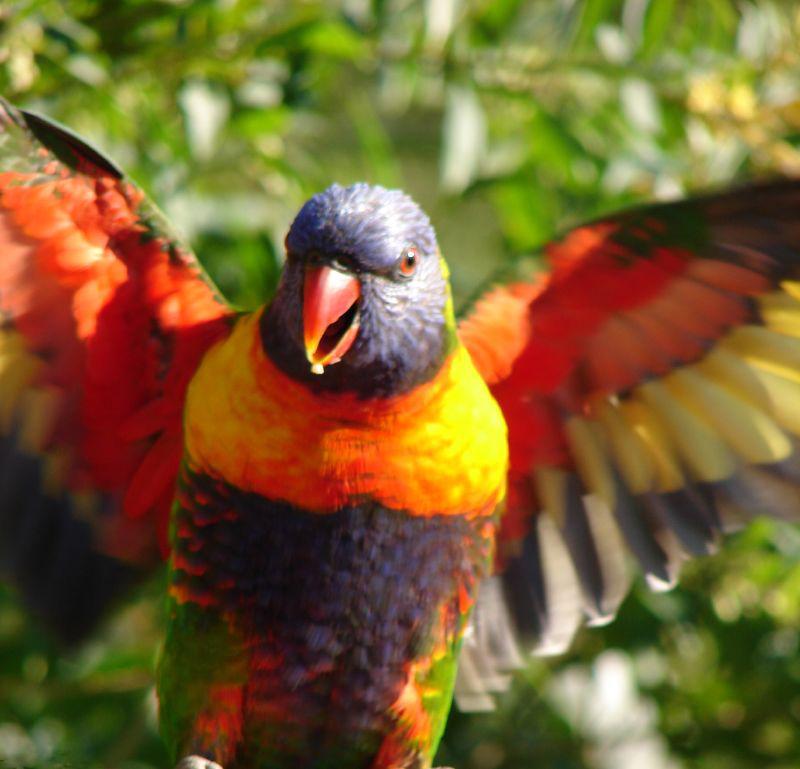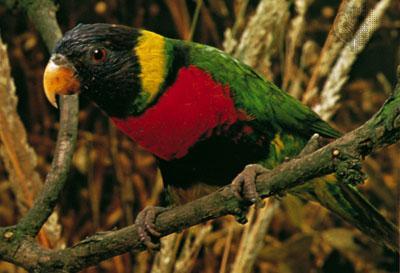The first image is the image on the left, the second image is the image on the right. Given the left and right images, does the statement "The right hand image shows exactly two birds perched on the same branch and looking the same direction." hold true? Answer yes or no. No. The first image is the image on the left, the second image is the image on the right. Evaluate the accuracy of this statement regarding the images: "There are exactly two parrots perched on a branch in the right image.". Is it true? Answer yes or no. No. 